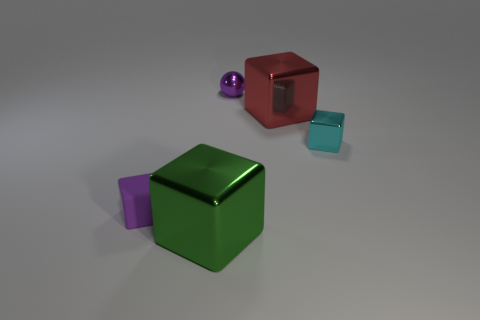How many objects are larger than the metal ball? There are two objects in the image that are larger than the metal ball. The red matte block and the green block both appear to exceed the size of the metal ball when compared visually. 